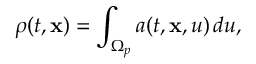Convert formula to latex. <formula><loc_0><loc_0><loc_500><loc_500>\rho ( t , x ) = \int _ { \Omega _ { p } } a ( t , x , u ) \, d u ,</formula> 